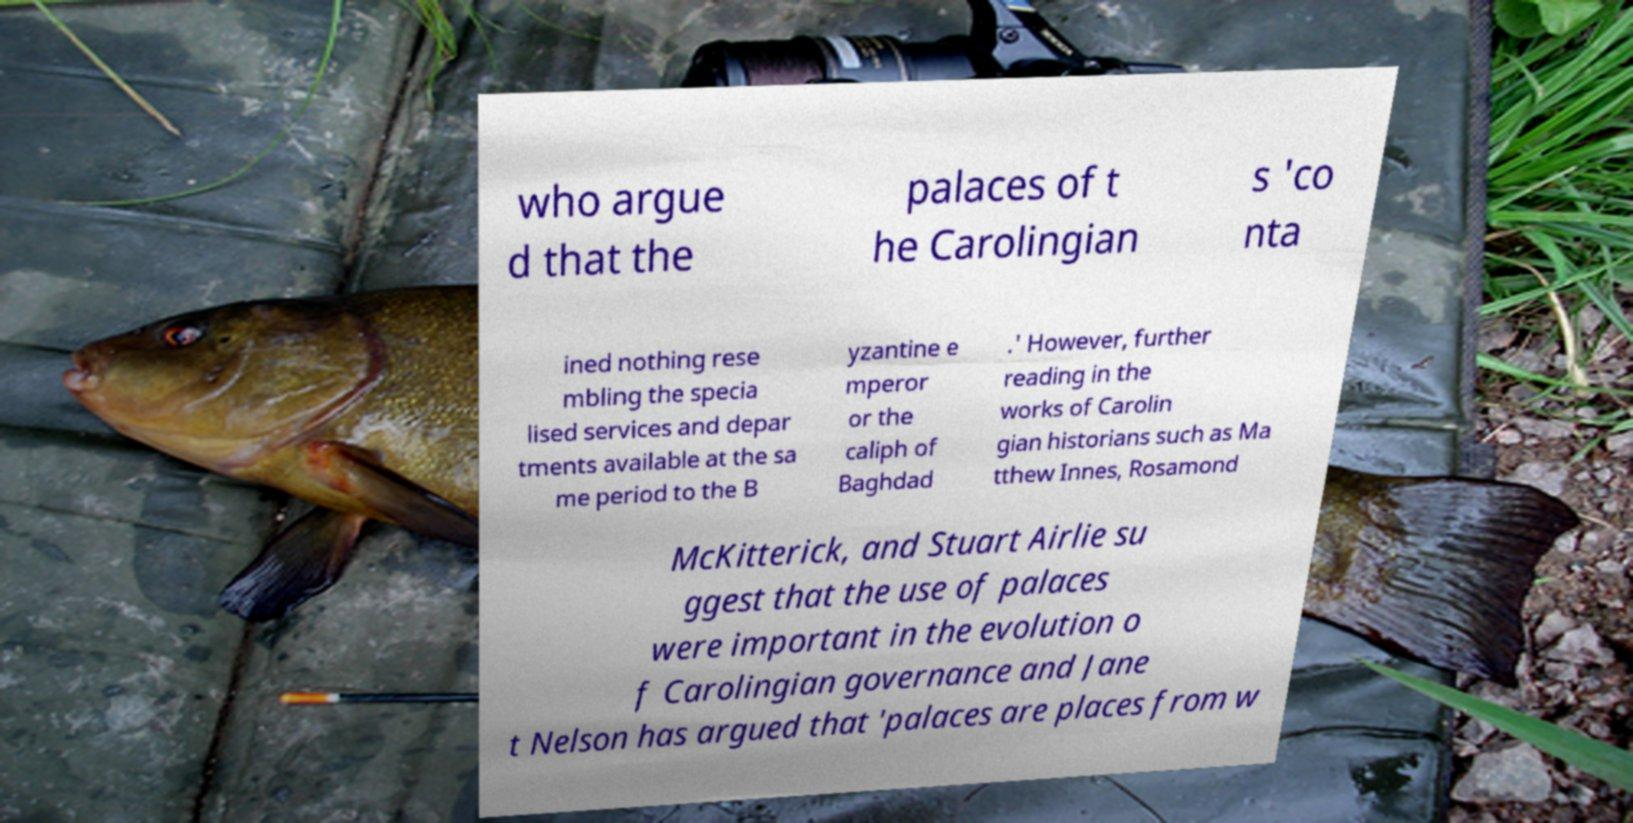Please read and relay the text visible in this image. What does it say? who argue d that the palaces of t he Carolingian s 'co nta ined nothing rese mbling the specia lised services and depar tments available at the sa me period to the B yzantine e mperor or the caliph of Baghdad .' However, further reading in the works of Carolin gian historians such as Ma tthew Innes, Rosamond McKitterick, and Stuart Airlie su ggest that the use of palaces were important in the evolution o f Carolingian governance and Jane t Nelson has argued that 'palaces are places from w 